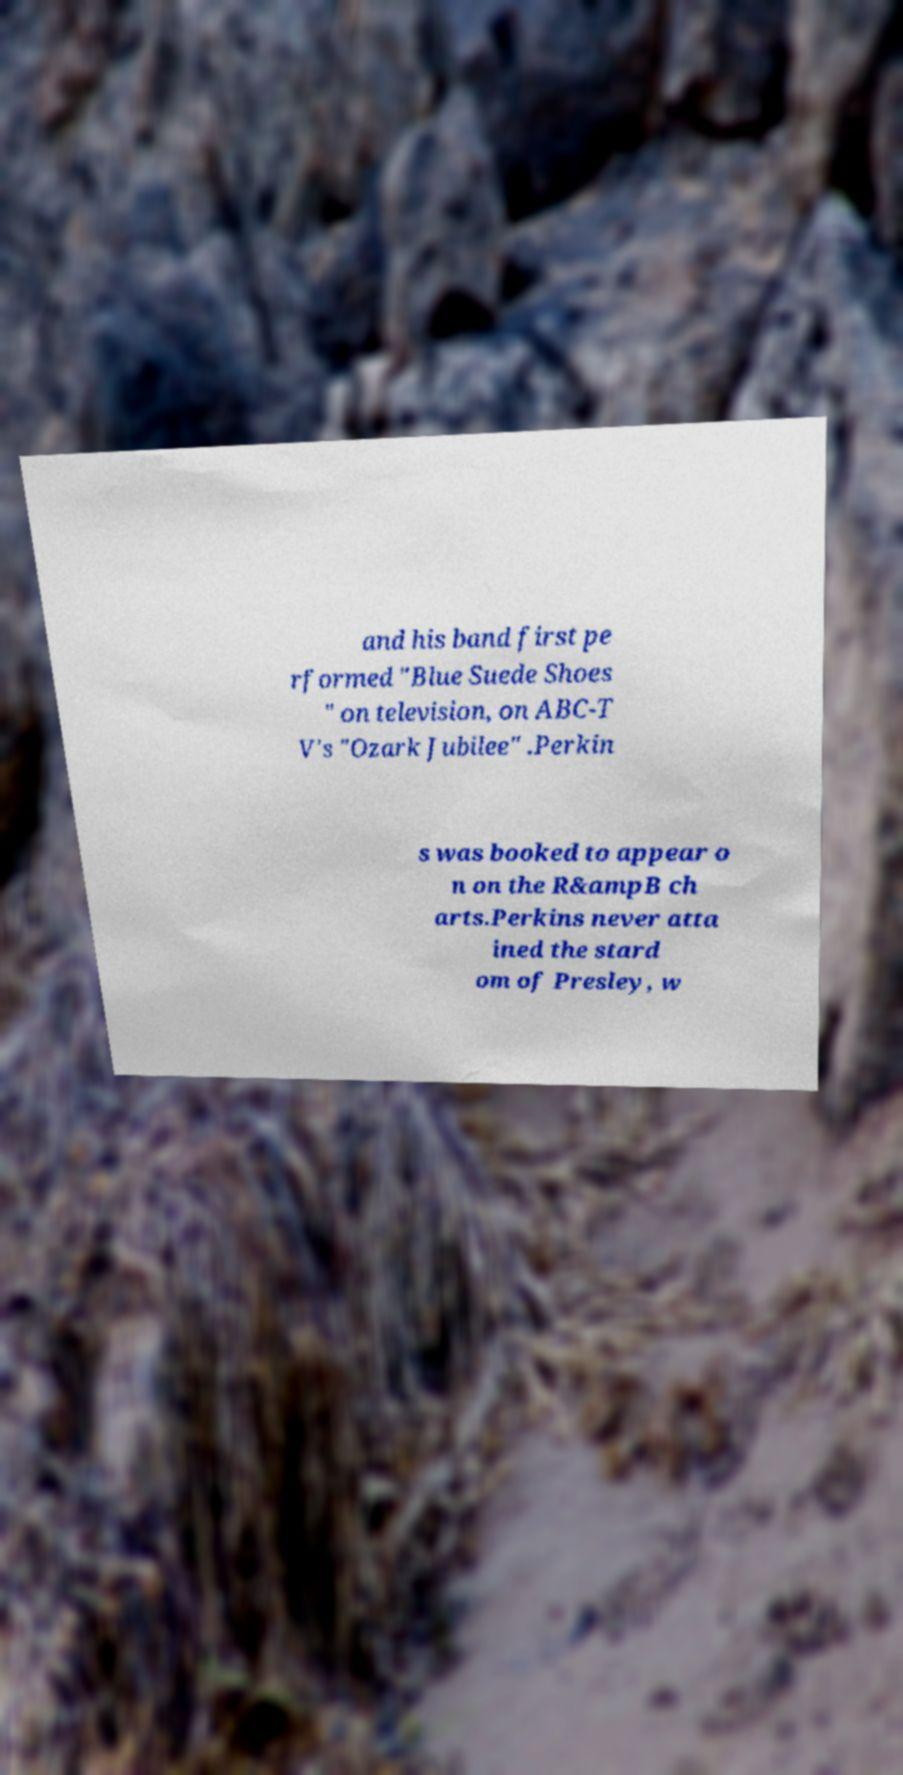Can you accurately transcribe the text from the provided image for me? and his band first pe rformed "Blue Suede Shoes " on television, on ABC-T V's "Ozark Jubilee" .Perkin s was booked to appear o n on the R&ampB ch arts.Perkins never atta ined the stard om of Presley, w 